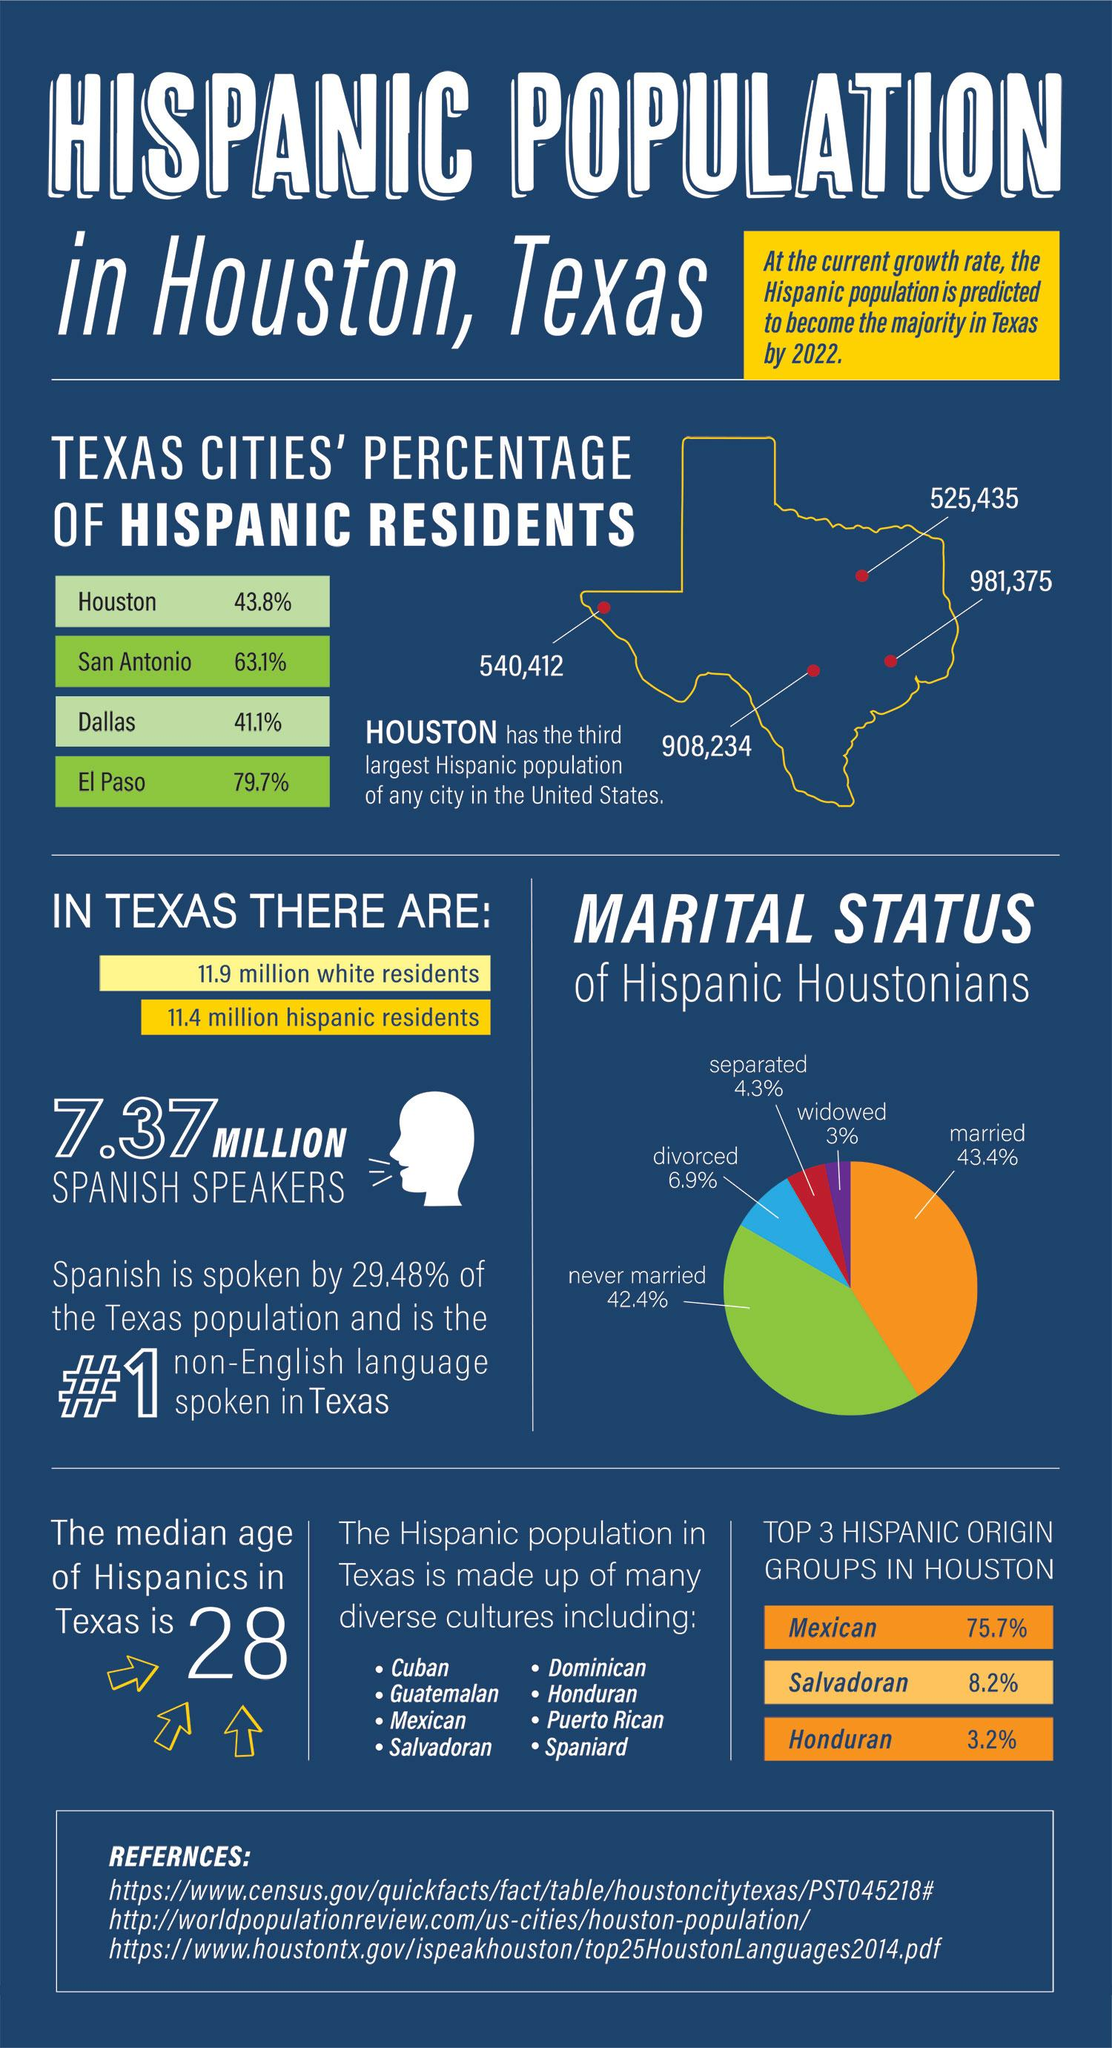List a handful of essential elements in this visual. The percentage difference between married and unmarried Hispanics in Houston is 1%. Houston, the city in Texas, has the highest number of population. According to the data, 14.2% of Hispanics have the marital status of single. El Paso, Texas has the highest percentage of Hispanics among all cities in the state. 